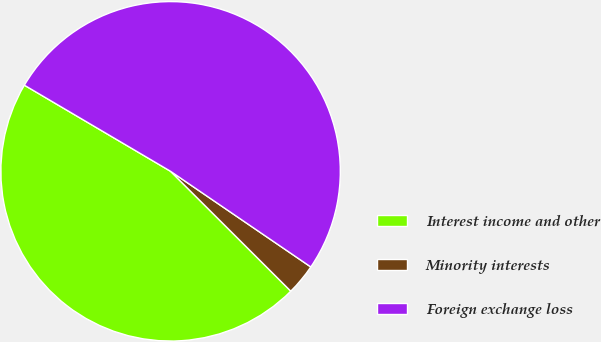<chart> <loc_0><loc_0><loc_500><loc_500><pie_chart><fcel>Interest income and other<fcel>Minority interests<fcel>Foreign exchange loss<nl><fcel>45.99%<fcel>2.95%<fcel>51.05%<nl></chart> 